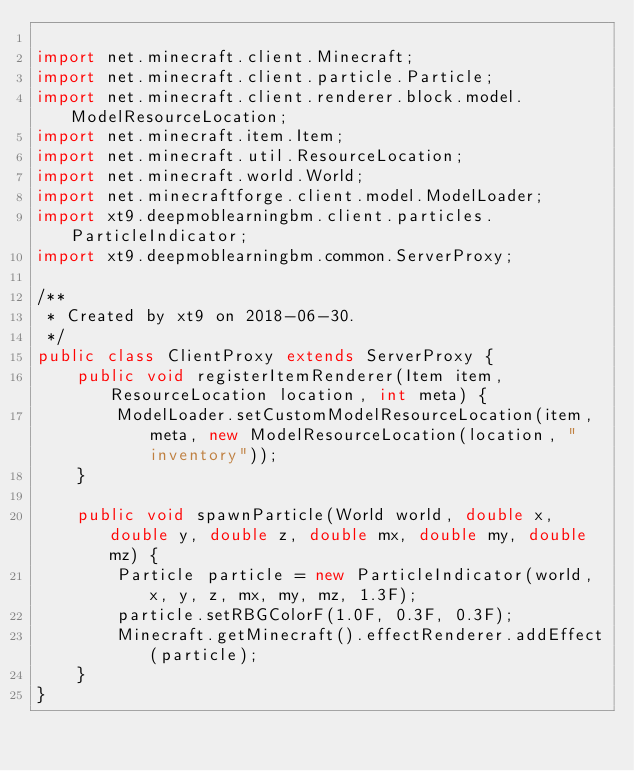Convert code to text. <code><loc_0><loc_0><loc_500><loc_500><_Java_>
import net.minecraft.client.Minecraft;
import net.minecraft.client.particle.Particle;
import net.minecraft.client.renderer.block.model.ModelResourceLocation;
import net.minecraft.item.Item;
import net.minecraft.util.ResourceLocation;
import net.minecraft.world.World;
import net.minecraftforge.client.model.ModelLoader;
import xt9.deepmoblearningbm.client.particles.ParticleIndicator;
import xt9.deepmoblearningbm.common.ServerProxy;

/**
 * Created by xt9 on 2018-06-30.
 */
public class ClientProxy extends ServerProxy {
    public void registerItemRenderer(Item item, ResourceLocation location, int meta) {
        ModelLoader.setCustomModelResourceLocation(item, meta, new ModelResourceLocation(location, "inventory"));
    }

    public void spawnParticle(World world, double x, double y, double z, double mx, double my, double mz) {
        Particle particle = new ParticleIndicator(world, x, y, z, mx, my, mz, 1.3F);
        particle.setRBGColorF(1.0F, 0.3F, 0.3F);
        Minecraft.getMinecraft().effectRenderer.addEffect(particle);
    }
}
</code> 